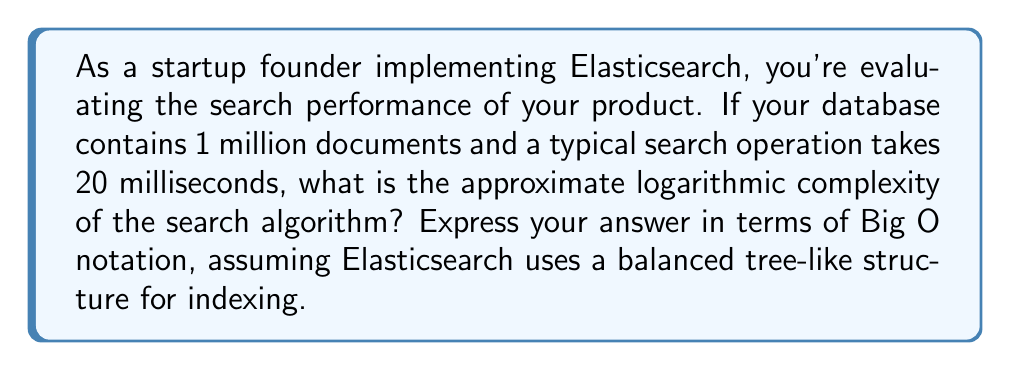Can you answer this question? To determine the logarithmic complexity of the search algorithm, we need to consider the following:

1. Elasticsearch uses inverted indices, which are typically implemented as balanced tree-like structures (e.g., B-trees).

2. The time complexity of searching in a balanced tree structure is generally $O(\log n)$, where $n$ is the number of elements.

3. In this case, we have 1 million documents, so $n = 10^6$.

4. The actual time taken (20 milliseconds) is not directly relevant to the Big O notation, as it represents the constant factor.

5. To express the complexity, we use the logarithm with base 2, as it's commonly used in computer science.

The logarithmic complexity can be expressed as:

$$O(\log_2 n) = O(\log_2 10^6)$$

We can simplify this further:

$$\log_2 10^6 = \log_2 (10^3 \cdot 10^3) = \log_2 10^3 + \log_2 10^3 = 2 \log_2 10^3$$

$$\log_2 10^3 \approx 9.97$$

So, $2 \log_2 10^3 \approx 19.93$

However, in Big O notation, we drop constant factors and express the complexity in terms of the input size. Therefore, the final complexity remains $O(\log n)$.
Answer: $O(\log n)$ 